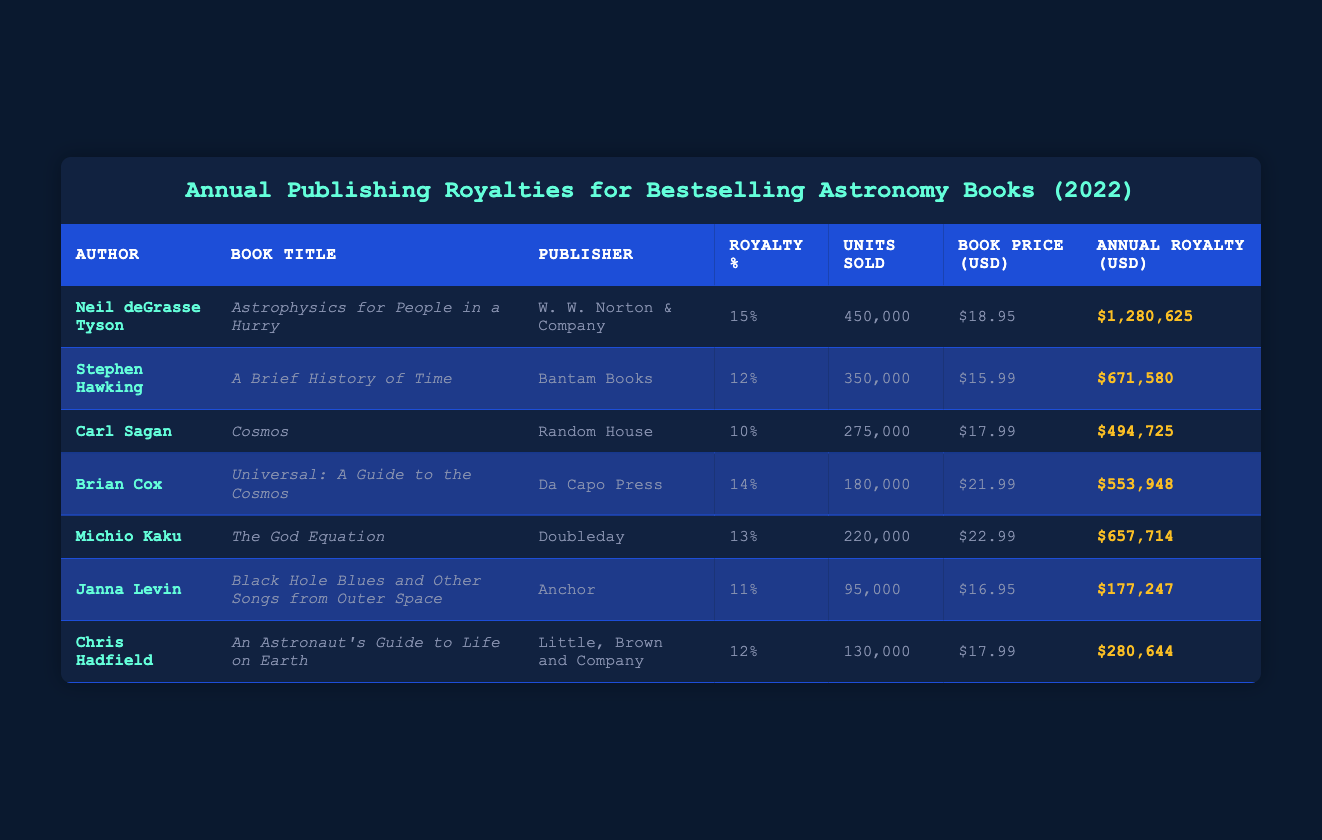What is the annual royalty for Neil deGrasse Tyson's book? The table lists Neil deGrasse Tyson as the author of "Astrophysics for People in a Hurry," and under the column "Annual Royalty (USD)," the value is $1,280,625.
Answer: $1,280,625 Who published "Cosmos" and what is its annual royalty? The author of "Cosmos" is Carl Sagan, and the publisher is Random House. The annual royalty is found under the "Annual Royalty (USD)" column, which shows $494,725.
Answer: Random House, $494,725 Which author's book sold the most units, and how many units did it sell? By examining the "Units Sold" column, Neil deGrasse Tyson has the highest count at 450,000 units sold for "Astrophysics for People in a Hurry."
Answer: Neil deGrasse Tyson, 450,000 units What is the average annual royalty of the books listed? To find the average, sum all the annual royalties (1,280,625 + 671,580 + 494,725 + 553,948 + 657,714 + 177,247 + 280,644 = 3,716,484) and divide by the number of entries (7). Thus, the average is 3,716,484 / 7 = 530,926.29.
Answer: 530,926.29 Is Stephen Hawking's book royalty higher than Michio Kaku's? The annual royalties are $671,580 for Stephen Hawking's "A Brief History of Time" and $657,714 for Michio Kaku's "The God Equation." Since $671,580 is greater than $657,714, the statement is true.
Answer: Yes What percentage royal does Janna Levin receive compared to Neil deGrasse Tyson? Janna Levin receives 11% for her book while Neil deGrasse Tyson receives 15%. Since 11% is less than 15%, the answer indicates that Janna Levin's royalty percentage is lower.
Answer: Lower What is the total number of units sold for the books by Michio Kaku and Brian Cox combined? Michio Kaku's book sold 220,000 units and Brian Cox's sold 180,000 units. Adding both numbers together (200,000 + 180,000) gives a total of 400,000 units sold.
Answer: 400,000 units How much does Chris Hadfield receive as an annual royalty compared to Carl Sagan? Chris Hadfield's annual royalty is $280,644, while Carl Sagan's is $494,725. Since $280,644 is less than $494,725, the comparison indicates Chris Hadfield receives a lower royalty.
Answer: Lower Which author has the second-highest annual royalty and what is the amount? By reviewing the annual royalties, Neil deGrasse Tyson has the highest at $1,280,625, followed by Stephen Hawking with $671,580. Thus, Stephen Hawking holds the second-highest annual royalty.
Answer: Stephen Hawking, $671,580 